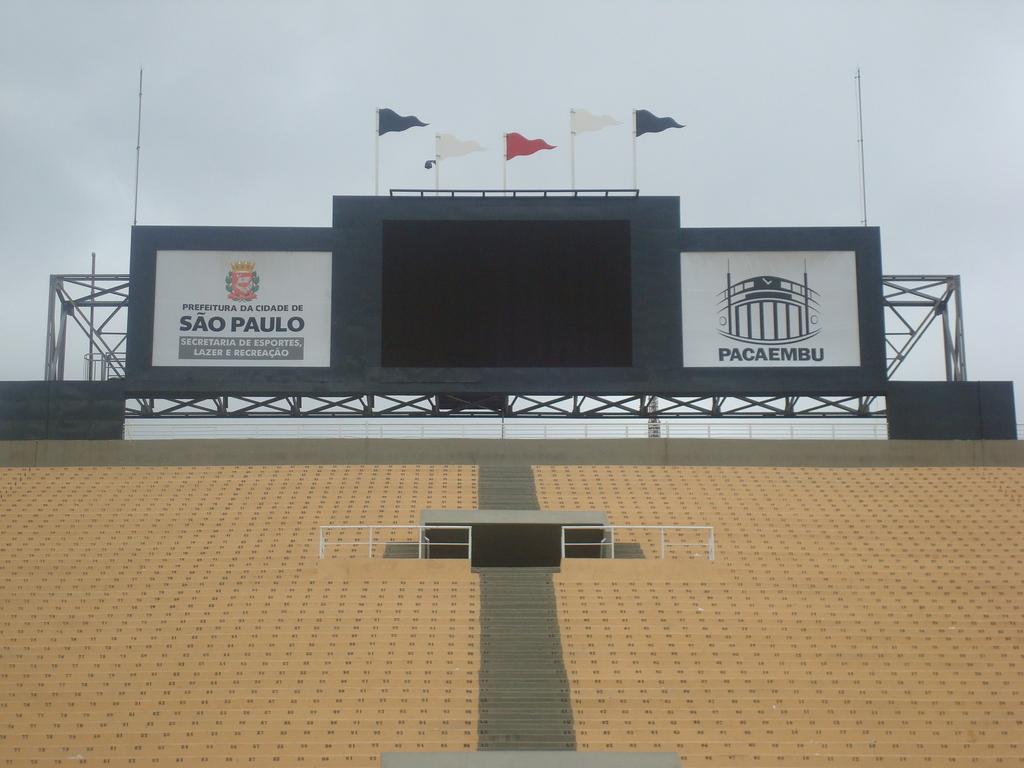What is the brand mentioned on the right side?
Give a very brief answer. Pacaembu. 